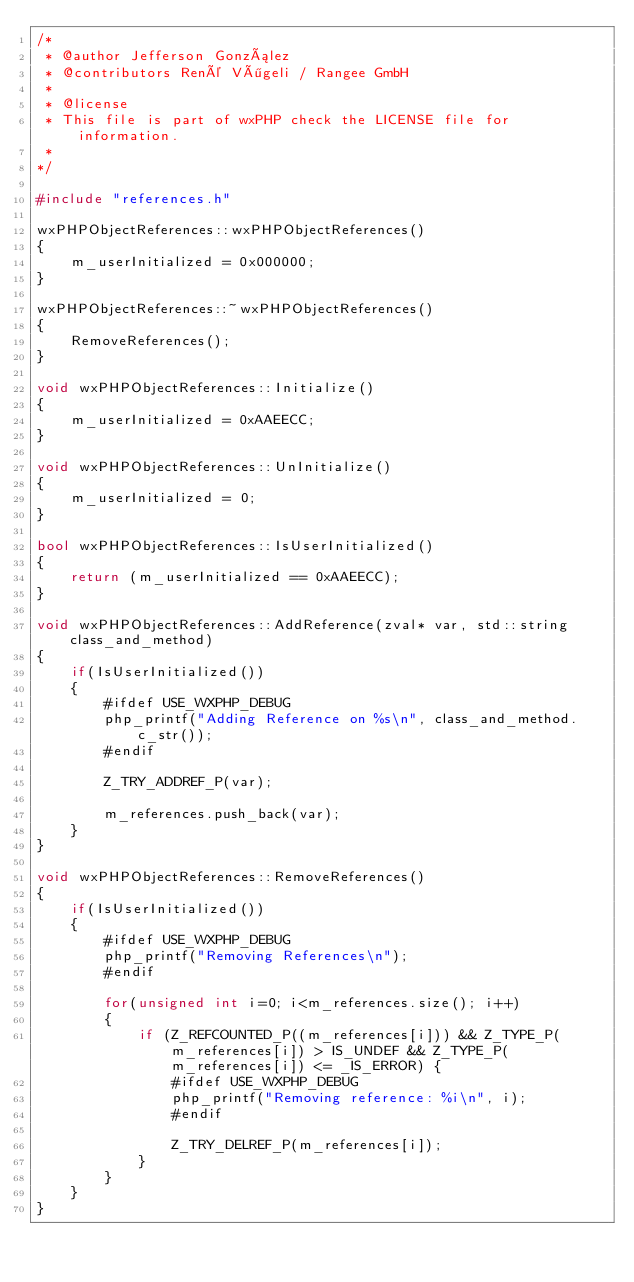<code> <loc_0><loc_0><loc_500><loc_500><_C++_>/*
 * @author Jefferson González
 * @contributors René Vögeli / Rangee GmbH
 *
 * @license
 * This file is part of wxPHP check the LICENSE file for information.
 *
*/

#include "references.h"

wxPHPObjectReferences::wxPHPObjectReferences()
{
    m_userInitialized = 0x000000;
}

wxPHPObjectReferences::~wxPHPObjectReferences()
{
    RemoveReferences();
}

void wxPHPObjectReferences::Initialize()
{
    m_userInitialized = 0xAAEECC;
}

void wxPHPObjectReferences::UnInitialize()
{
    m_userInitialized = 0;
}

bool wxPHPObjectReferences::IsUserInitialized()
{
    return (m_userInitialized == 0xAAEECC);
}

void wxPHPObjectReferences::AddReference(zval* var, std::string class_and_method)
{
    if(IsUserInitialized())
    {
        #ifdef USE_WXPHP_DEBUG
        php_printf("Adding Reference on %s\n", class_and_method.c_str());
        #endif

        Z_TRY_ADDREF_P(var);

        m_references.push_back(var);
    }
}

void wxPHPObjectReferences::RemoveReferences()
{
    if(IsUserInitialized())
    {
        #ifdef USE_WXPHP_DEBUG
        php_printf("Removing References\n");
        #endif

        for(unsigned int i=0; i<m_references.size(); i++)
        {
            if (Z_REFCOUNTED_P((m_references[i])) && Z_TYPE_P(m_references[i]) > IS_UNDEF && Z_TYPE_P(m_references[i]) <= _IS_ERROR) {
                #ifdef USE_WXPHP_DEBUG
                php_printf("Removing reference: %i\n", i);
                #endif

                Z_TRY_DELREF_P(m_references[i]);
            }
        }
    }
}
</code> 